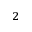<formula> <loc_0><loc_0><loc_500><loc_500>_ { 2 }</formula> 